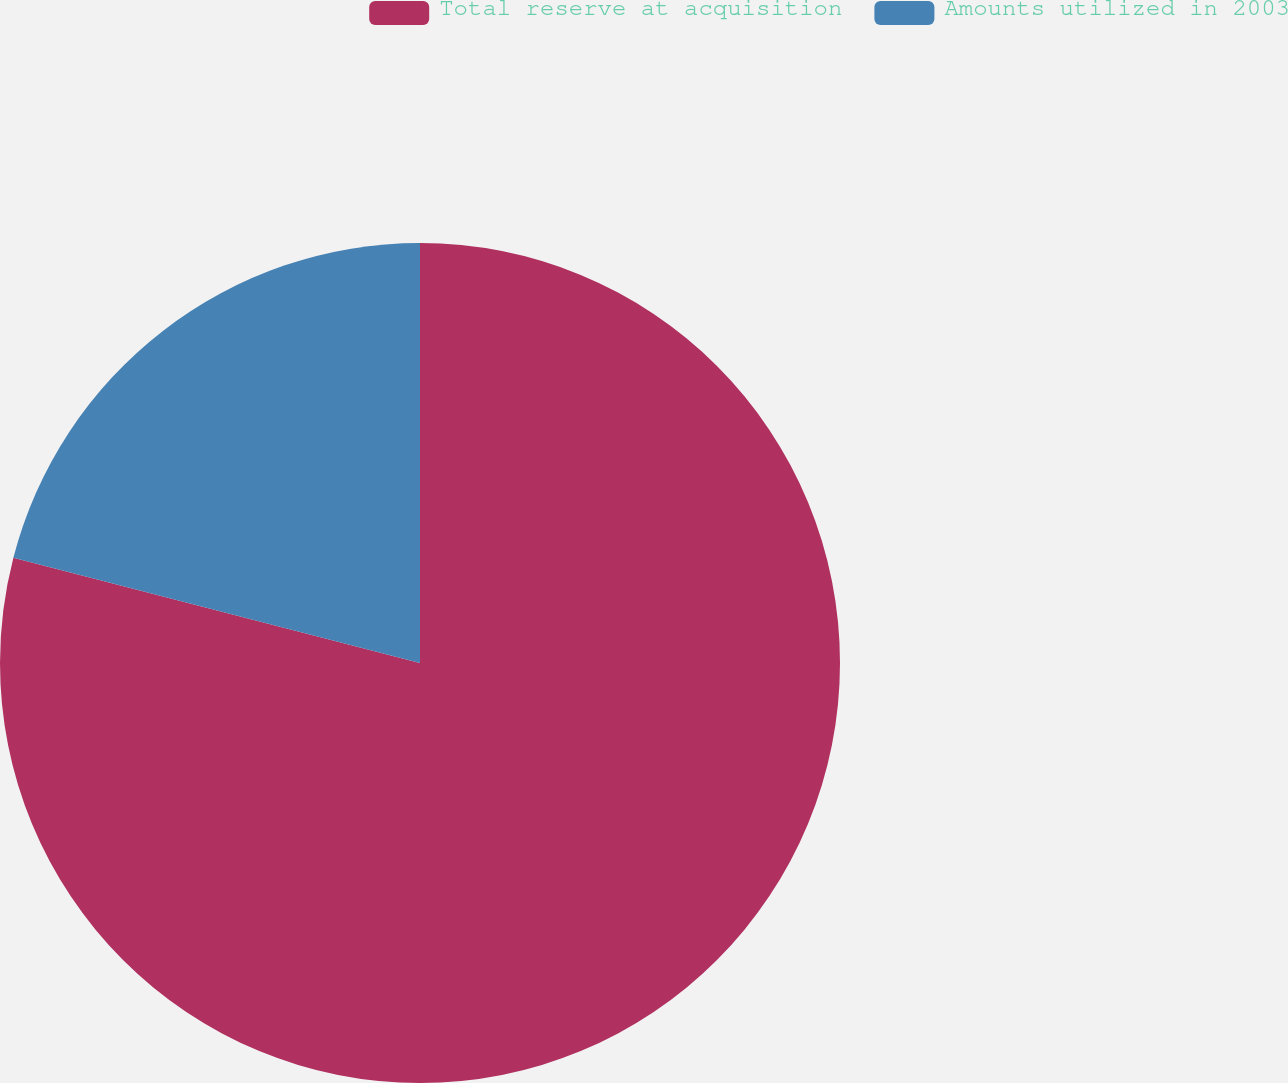Convert chart. <chart><loc_0><loc_0><loc_500><loc_500><pie_chart><fcel>Total reserve at acquisition<fcel>Amounts utilized in 2003<nl><fcel>79.03%<fcel>20.97%<nl></chart> 